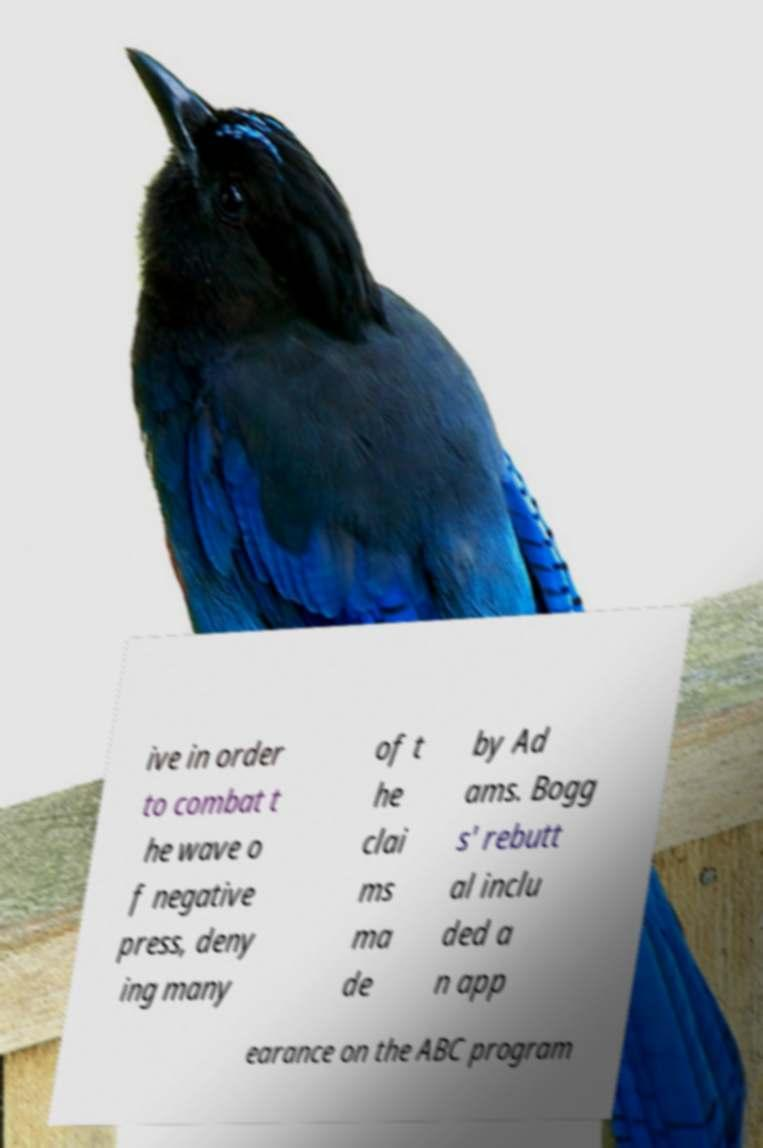There's text embedded in this image that I need extracted. Can you transcribe it verbatim? ive in order to combat t he wave o f negative press, deny ing many of t he clai ms ma de by Ad ams. Bogg s' rebutt al inclu ded a n app earance on the ABC program 